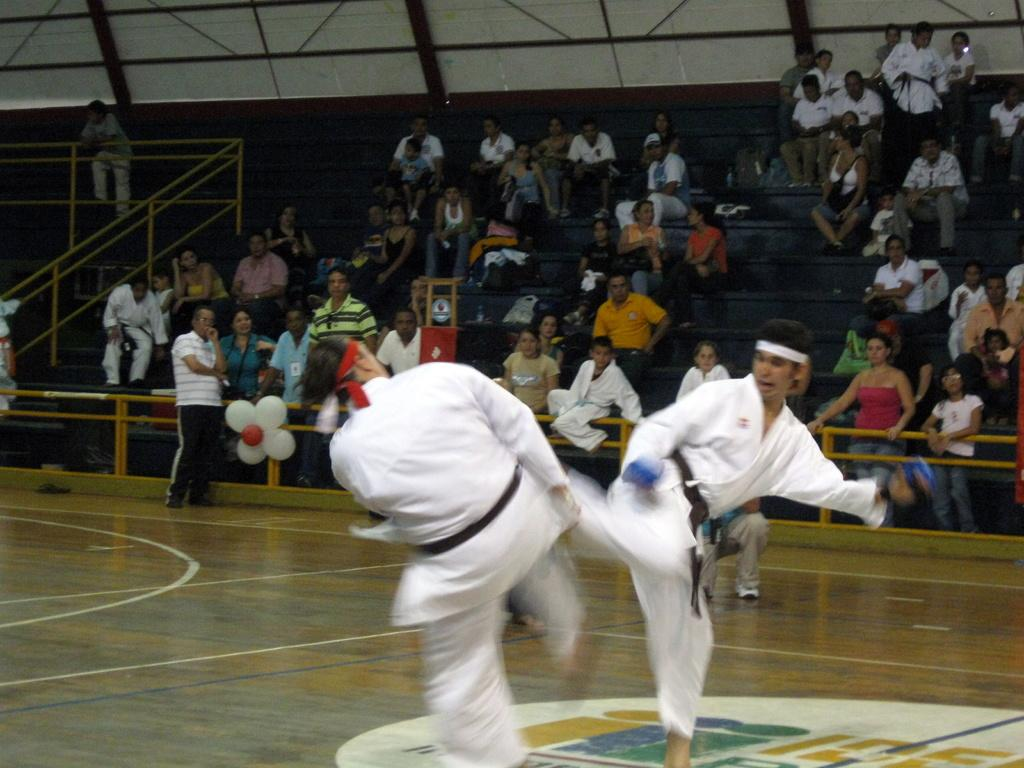Who is present in the image? There are people in the image. Where are the people located? The people are in a stadium. What is happening between two of the people? Two people are fighting. What can be seen beneath the people's feet in the image? There is a floor visible in the image. Are there any architectural features in the image? Yes, there are stairs in the image. What type of barrier is present in the image? There is fencing in the image. What is attached to the wall in the image? There is a wall with objects attached to it in the image. What type of drink is being served to the people in the image? There is no drink being served in the image; it features people in a stadium, with two of them fighting. 